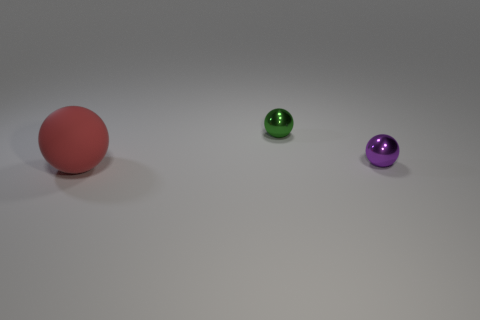How many blocks are either big rubber objects or metal objects?
Ensure brevity in your answer.  0. What number of objects are on the right side of the tiny metal sphere that is to the right of the shiny thing on the left side of the tiny purple object?
Offer a very short reply. 0. Is there a cyan ball that has the same material as the green object?
Provide a succinct answer. No. Does the red object have the same material as the small purple sphere?
Make the answer very short. No. What number of tiny metal things are on the left side of the green thing behind the purple thing?
Keep it short and to the point. 0. What number of purple objects are tiny spheres or matte balls?
Provide a short and direct response. 1. What is the color of the object that is the same size as the green sphere?
Keep it short and to the point. Purple. How many red matte objects have the same shape as the small purple metallic thing?
Your response must be concise. 1. There is a purple ball; does it have the same size as the thing that is in front of the tiny purple shiny object?
Keep it short and to the point. No. What shape is the big rubber object that is on the left side of the metallic object that is to the left of the small purple metallic thing?
Provide a short and direct response. Sphere. 